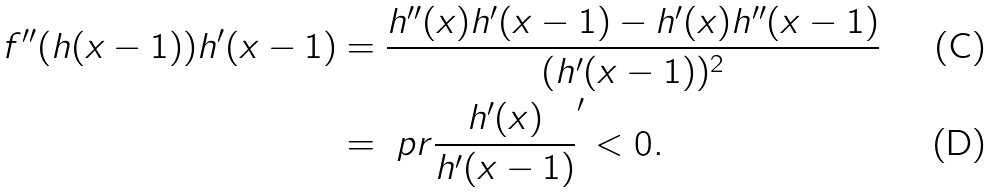Convert formula to latex. <formula><loc_0><loc_0><loc_500><loc_500>f ^ { \prime \prime } ( h ( x - 1 ) ) h ^ { \prime } ( x - 1 ) & = \frac { h ^ { \prime \prime } ( x ) h ^ { \prime } ( x - 1 ) - h ^ { \prime } ( x ) h ^ { \prime \prime } ( x - 1 ) } { ( h ^ { \prime } ( x - 1 ) ) ^ { 2 } } \\ & = \ p r { \frac { h ^ { \prime } ( x ) } { h ^ { \prime } ( x - 1 ) } } ^ { \prime } < 0 .</formula> 